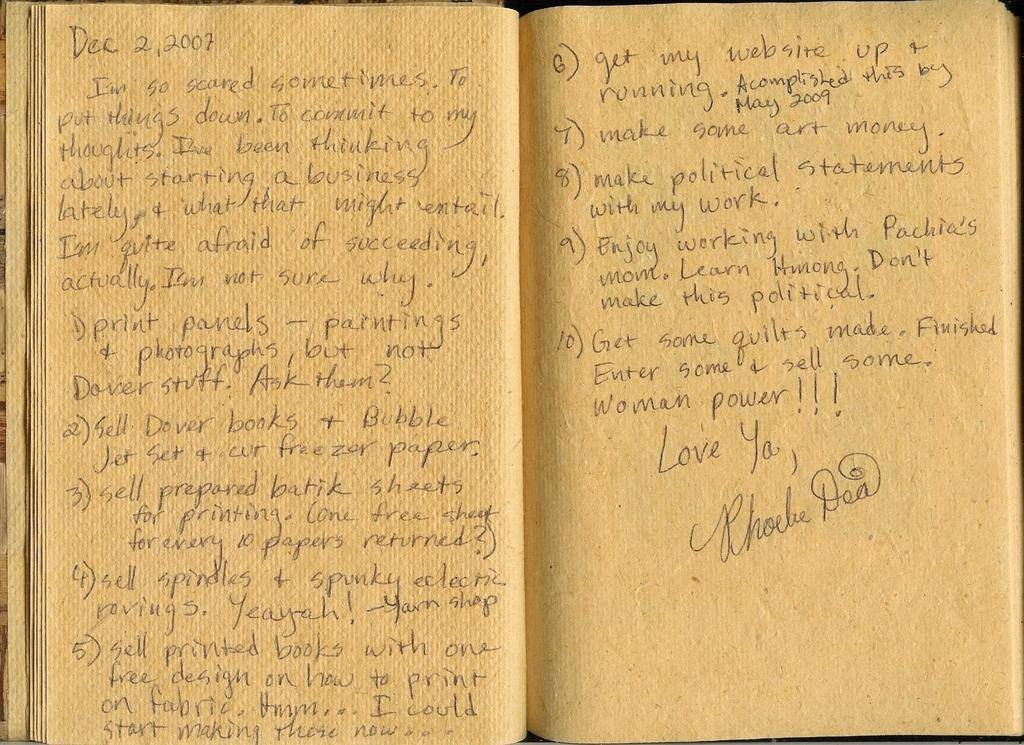<image>
Provide a brief description of the given image. phoebe dea writes in pencil within a journal 